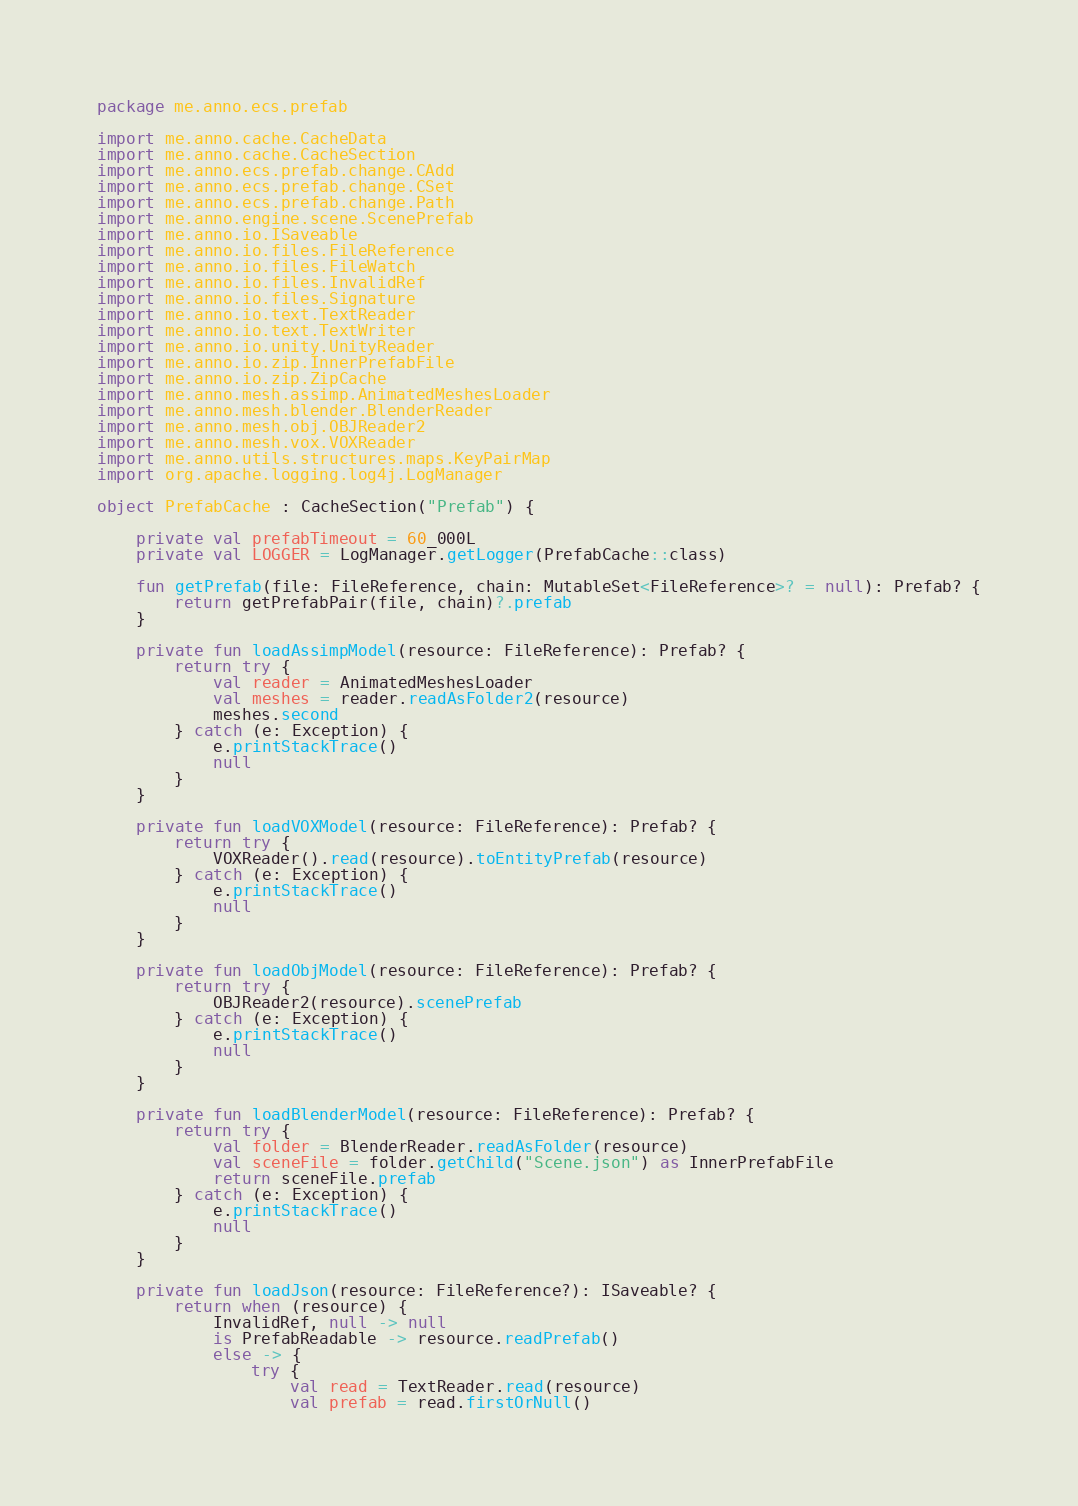<code> <loc_0><loc_0><loc_500><loc_500><_Kotlin_>package me.anno.ecs.prefab

import me.anno.cache.CacheData
import me.anno.cache.CacheSection
import me.anno.ecs.prefab.change.CAdd
import me.anno.ecs.prefab.change.CSet
import me.anno.ecs.prefab.change.Path
import me.anno.engine.scene.ScenePrefab
import me.anno.io.ISaveable
import me.anno.io.files.FileReference
import me.anno.io.files.FileWatch
import me.anno.io.files.InvalidRef
import me.anno.io.files.Signature
import me.anno.io.text.TextReader
import me.anno.io.text.TextWriter
import me.anno.io.unity.UnityReader
import me.anno.io.zip.InnerPrefabFile
import me.anno.io.zip.ZipCache
import me.anno.mesh.assimp.AnimatedMeshesLoader
import me.anno.mesh.blender.BlenderReader
import me.anno.mesh.obj.OBJReader2
import me.anno.mesh.vox.VOXReader
import me.anno.utils.structures.maps.KeyPairMap
import org.apache.logging.log4j.LogManager

object PrefabCache : CacheSection("Prefab") {

    private val prefabTimeout = 60_000L
    private val LOGGER = LogManager.getLogger(PrefabCache::class)

    fun getPrefab(file: FileReference, chain: MutableSet<FileReference>? = null): Prefab? {
        return getPrefabPair(file, chain)?.prefab
    }

    private fun loadAssimpModel(resource: FileReference): Prefab? {
        return try {
            val reader = AnimatedMeshesLoader
            val meshes = reader.readAsFolder2(resource)
            meshes.second
        } catch (e: Exception) {
            e.printStackTrace()
            null
        }
    }

    private fun loadVOXModel(resource: FileReference): Prefab? {
        return try {
            VOXReader().read(resource).toEntityPrefab(resource)
        } catch (e: Exception) {
            e.printStackTrace()
            null
        }
    }

    private fun loadObjModel(resource: FileReference): Prefab? {
        return try {
            OBJReader2(resource).scenePrefab
        } catch (e: Exception) {
            e.printStackTrace()
            null
        }
    }

    private fun loadBlenderModel(resource: FileReference): Prefab? {
        return try {
            val folder = BlenderReader.readAsFolder(resource)
            val sceneFile = folder.getChild("Scene.json") as InnerPrefabFile
            return sceneFile.prefab
        } catch (e: Exception) {
            e.printStackTrace()
            null
        }
    }

    private fun loadJson(resource: FileReference?): ISaveable? {
        return when (resource) {
            InvalidRef, null -> null
            is PrefabReadable -> resource.readPrefab()
            else -> {
                try {
                    val read = TextReader.read(resource)
                    val prefab = read.firstOrNull()</code> 